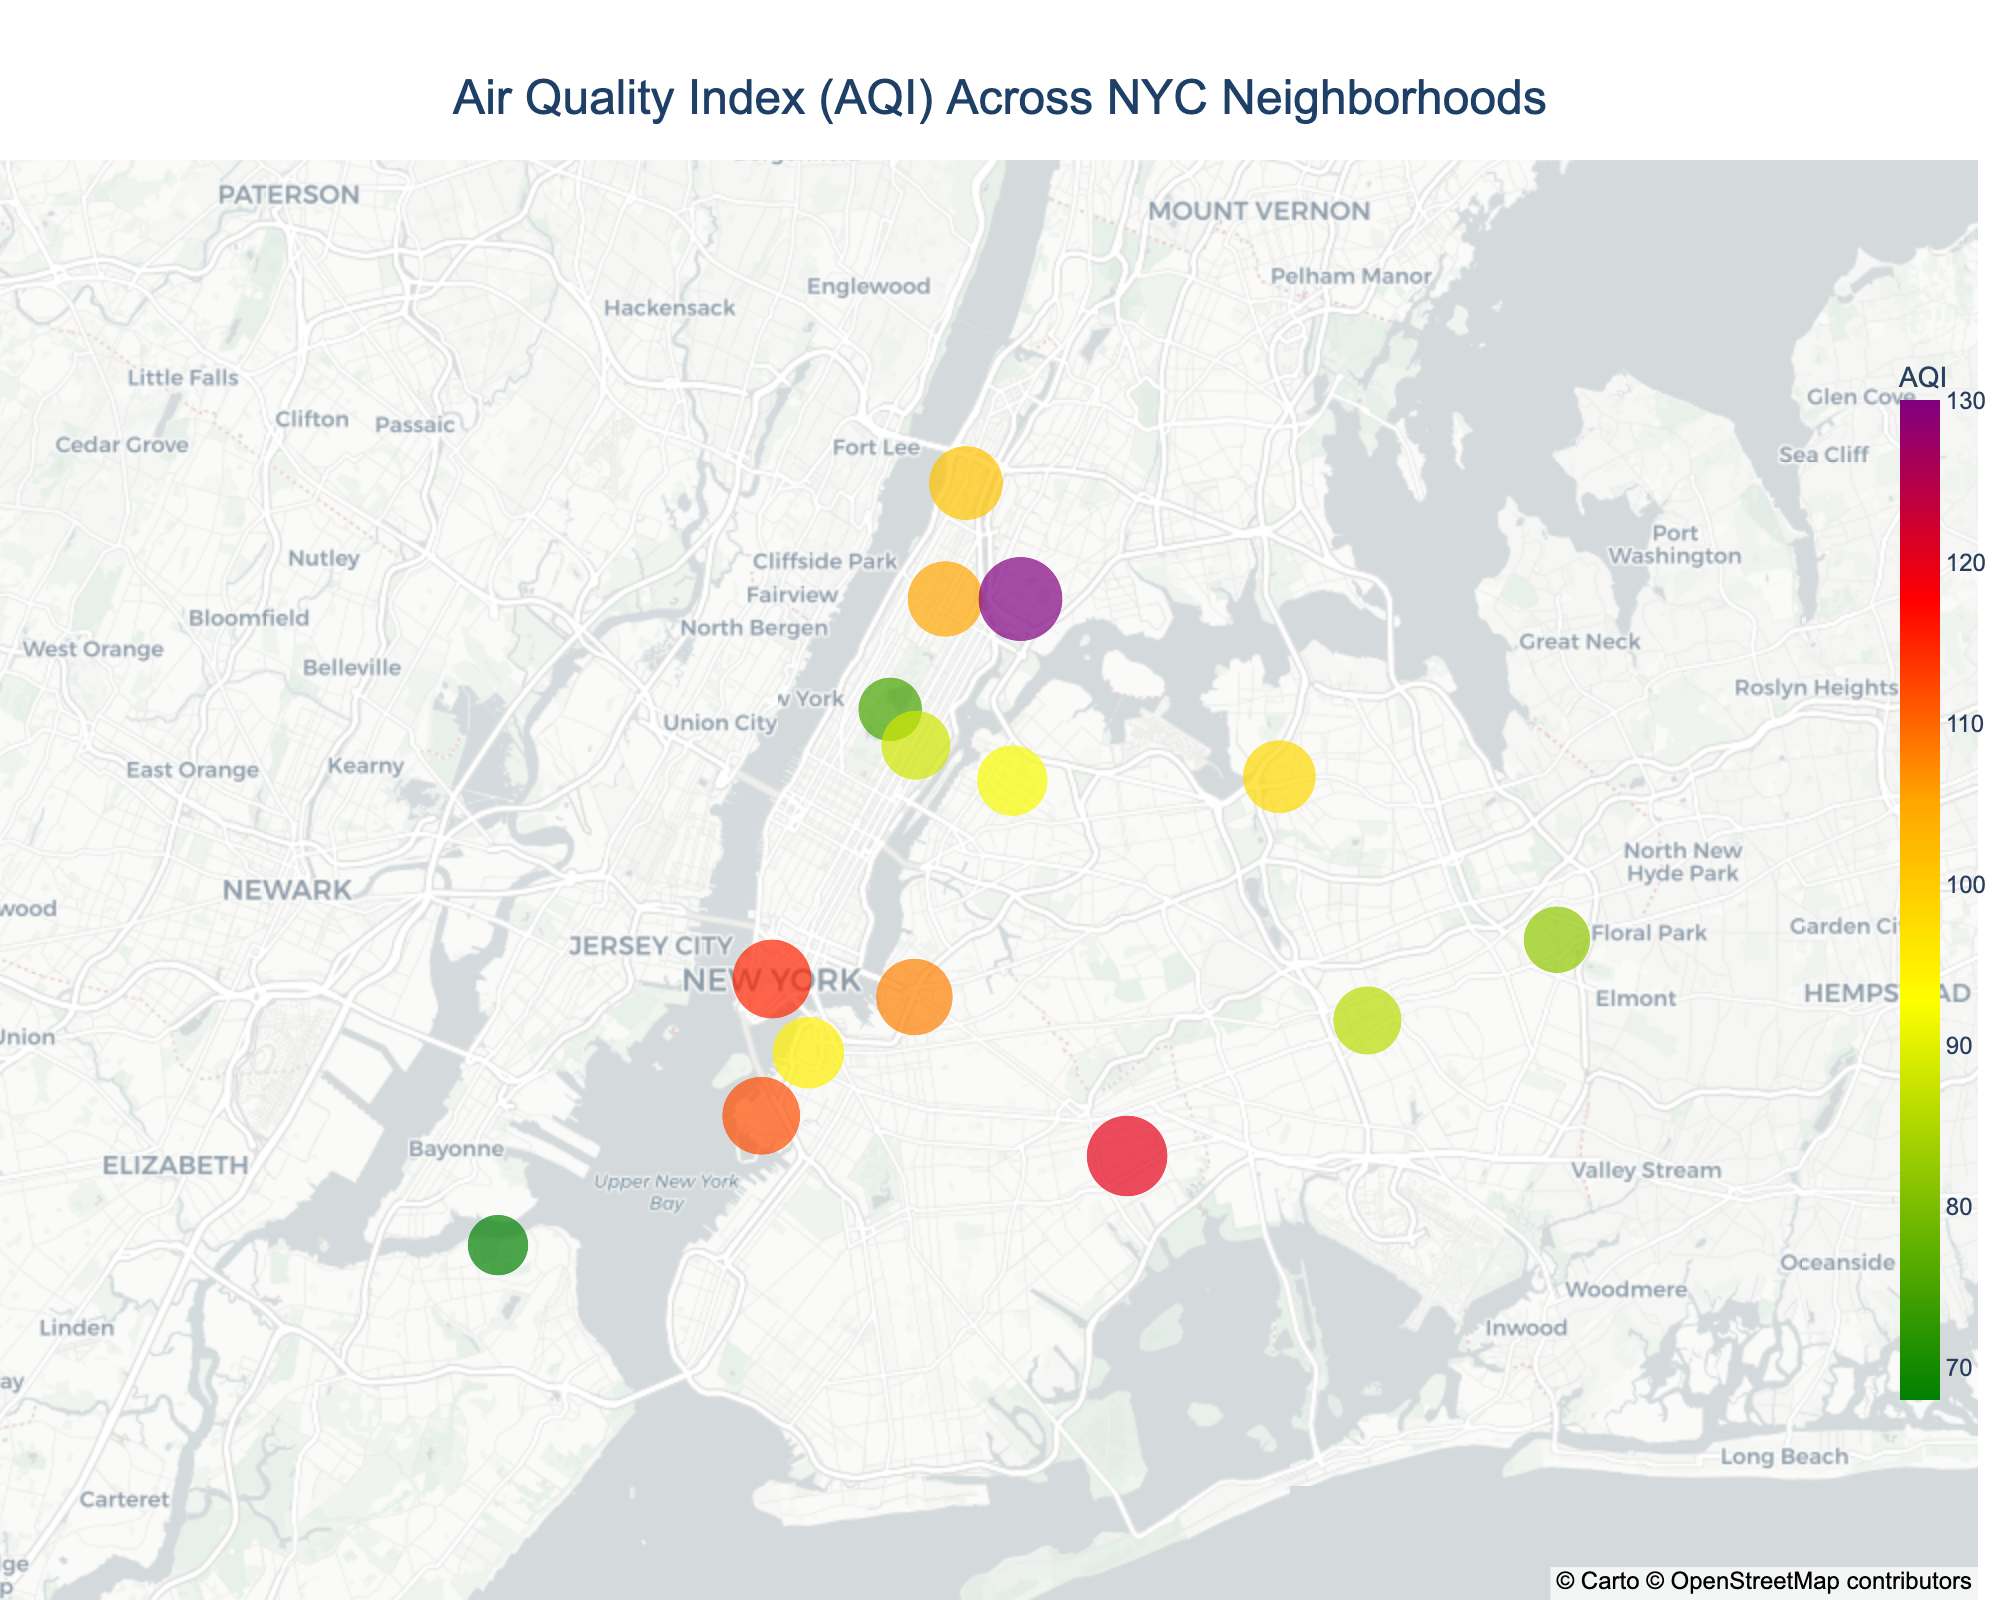What does the title of the figure indicate? The title of the figure is "Air Quality Index (AQI) Across NYC Neighborhoods," indicating that the plot shows the AQI measurements for different neighborhoods in New York City.
Answer: AQI Across NYC Neighborhoods Which neighborhood has the highest AQI? By examining the size and color density of the plotted points, South Bronx has the highest AQI value of 130.
Answer: South Bronx What color is used to represent the highest AQI values on the plot? The color scale indicates that the highest AQI values are represented in a shade of purple.
Answer: Purple How many neighborhoods have an AQI above 100? Identifying the neighborhoods with AQI values greater than 100, there are six instances: Downtown, South Bronx, Harlem, Red Hook, Williamsburg, and East New York.
Answer: Six What is the primary pollutant in the neighborhood with the second highest AQI? The neighborhood with the second highest AQI is Downtown with an AQI of 115, and the primary pollutant is PM2.5.
Answer: PM2.5 Which area has the lowest AQI and what is its primary pollutant? Staten Island North Shore has the lowest AQI of 68, and the primary pollutant is SO2.
Answer: Staten Island North Shore, SO2 Compare the AQI of Williamsburg and Central Park. Which one is higher? Williamsburg's AQI is 108, while Central Park's AQI is 75. Therefore, Williamsburg has a higher AQI.
Answer: Williamsburg What is the average AQI for neighborhoods with PM2.5 as the primary pollutant? The neighborhoods with PM2.5 as the primary pollutant are Downtown (AQI 115), South Bronx (AQI 130), East New York (AQI 120), and Astoria (AQI 92). The average AQI is calculated as (115 + 130 + 120 + 92)/4 = 114.25.
Answer: 114.25 In terms of distribution, which part of New York City seems to have higher pollution levels based on AQI? The central and southern parts, including Downtown, Red Hook, South Bronx, and East New York, show relatively higher AQI values.
Answer: Central and Southern parts How does the AQI of Red Hook compare to that of Upper East Side? The AQI of Red Hook is 112, whereas that of Upper East Side is 88. Therefore, Red Hook has a higher AQI.
Answer: Red Hook 